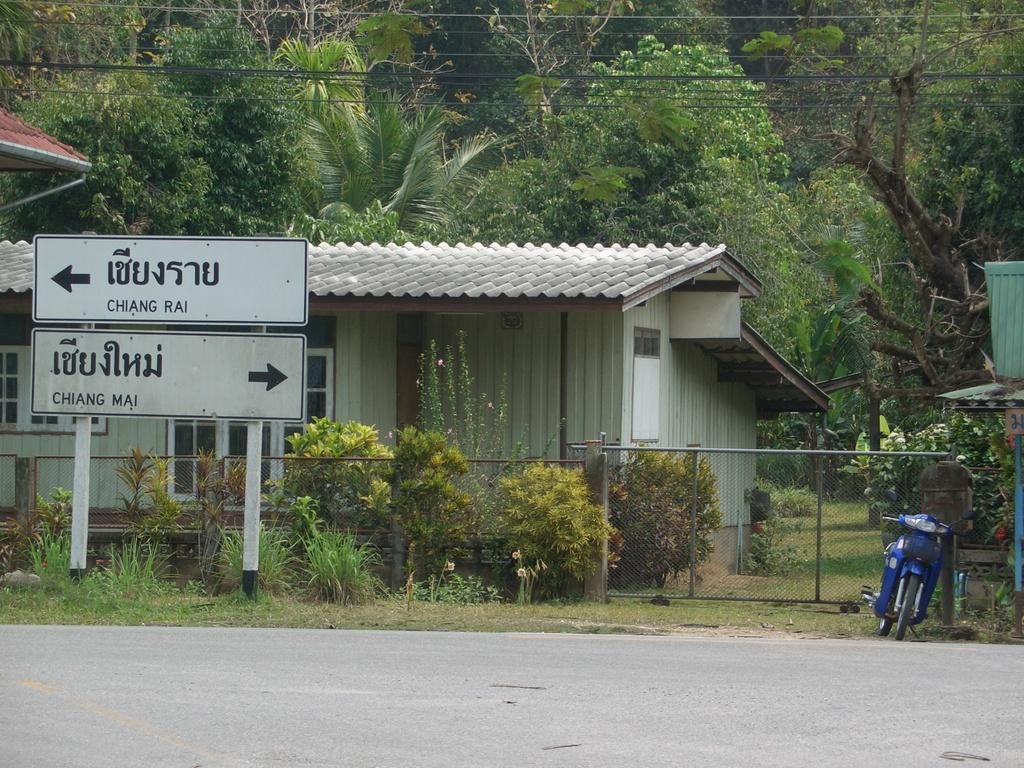What type of structure is visible in the image? There is a house in the image. What type of vegetation can be seen in the image? There are plants and trees in the image. What is the ground covered with in the image? There is grass in the image. What decorative item is present in the image? There is a banner in the image. What mode of transportation can be seen in the image? There is a motorcycle in the image. What type of lettuce is growing on the motorcycle in the image? There is no lettuce growing on the motorcycle in the image; it is a motorcycle, not a plant. 